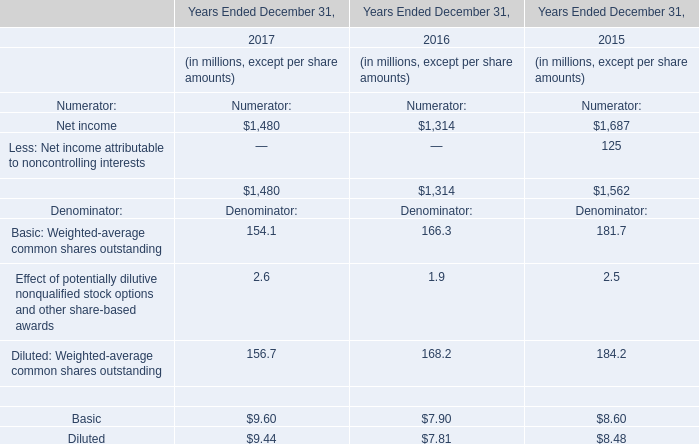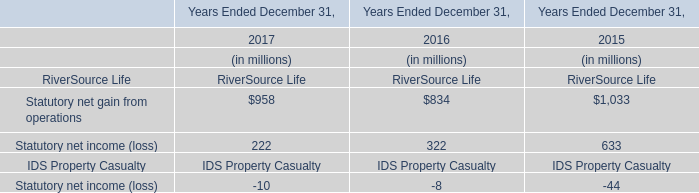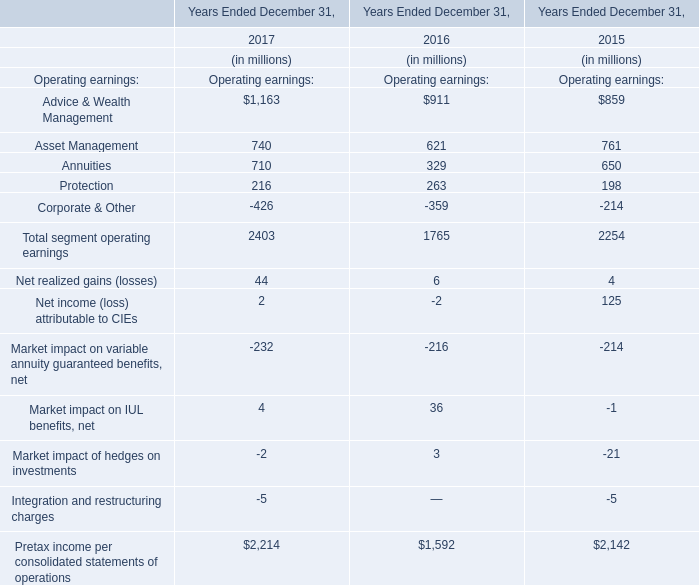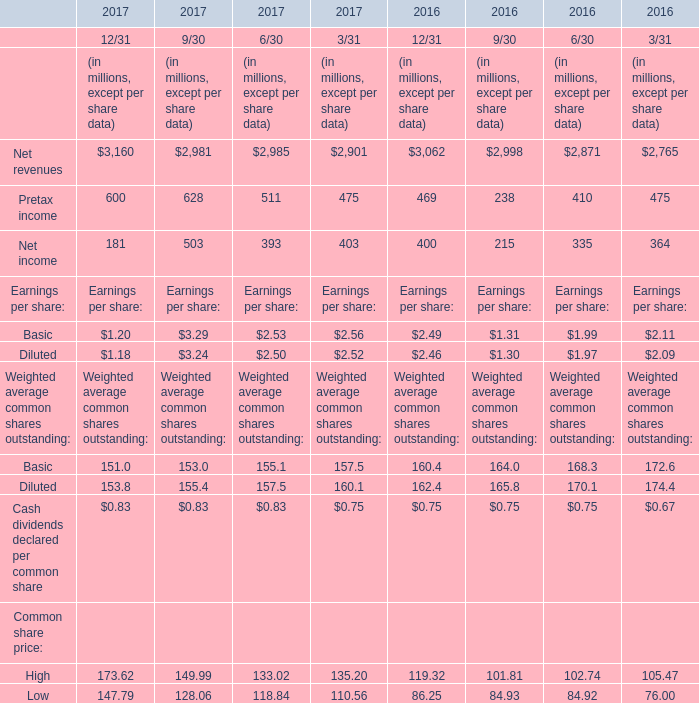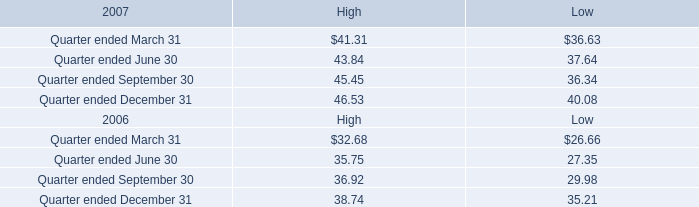In the year with the most Net revenues, what is the growth rate of Pretax income? (in %) 
Computations: (((((600 + 628) + 511) + 475) - (((469 + 238) + 410) + 475)) / (((469 + 238) + 410) + 475))
Answer: 0.3907. 